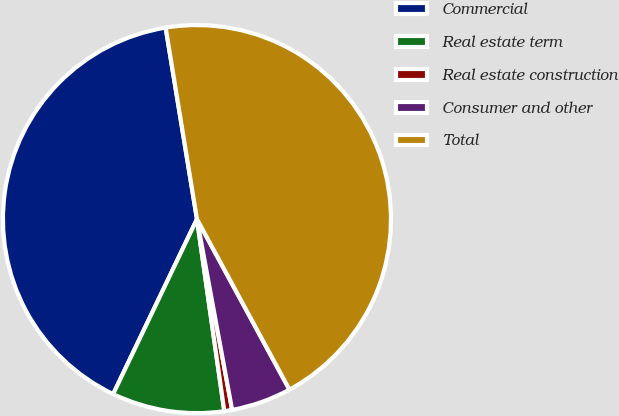Convert chart. <chart><loc_0><loc_0><loc_500><loc_500><pie_chart><fcel>Commercial<fcel>Real estate term<fcel>Real estate construction<fcel>Consumer and other<fcel>Total<nl><fcel>40.31%<fcel>9.36%<fcel>0.65%<fcel>5.01%<fcel>44.67%<nl></chart> 